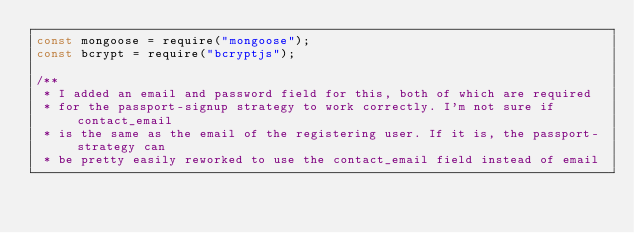Convert code to text. <code><loc_0><loc_0><loc_500><loc_500><_JavaScript_>const mongoose = require("mongoose");
const bcrypt = require("bcryptjs");

/**
 * I added an email and password field for this, both of which are required
 * for the passport-signup strategy to work correctly. I'm not sure if contact_email
 * is the same as the email of the registering user. If it is, the passport-strategy can 
 * be pretty easily reworked to use the contact_email field instead of email</code> 